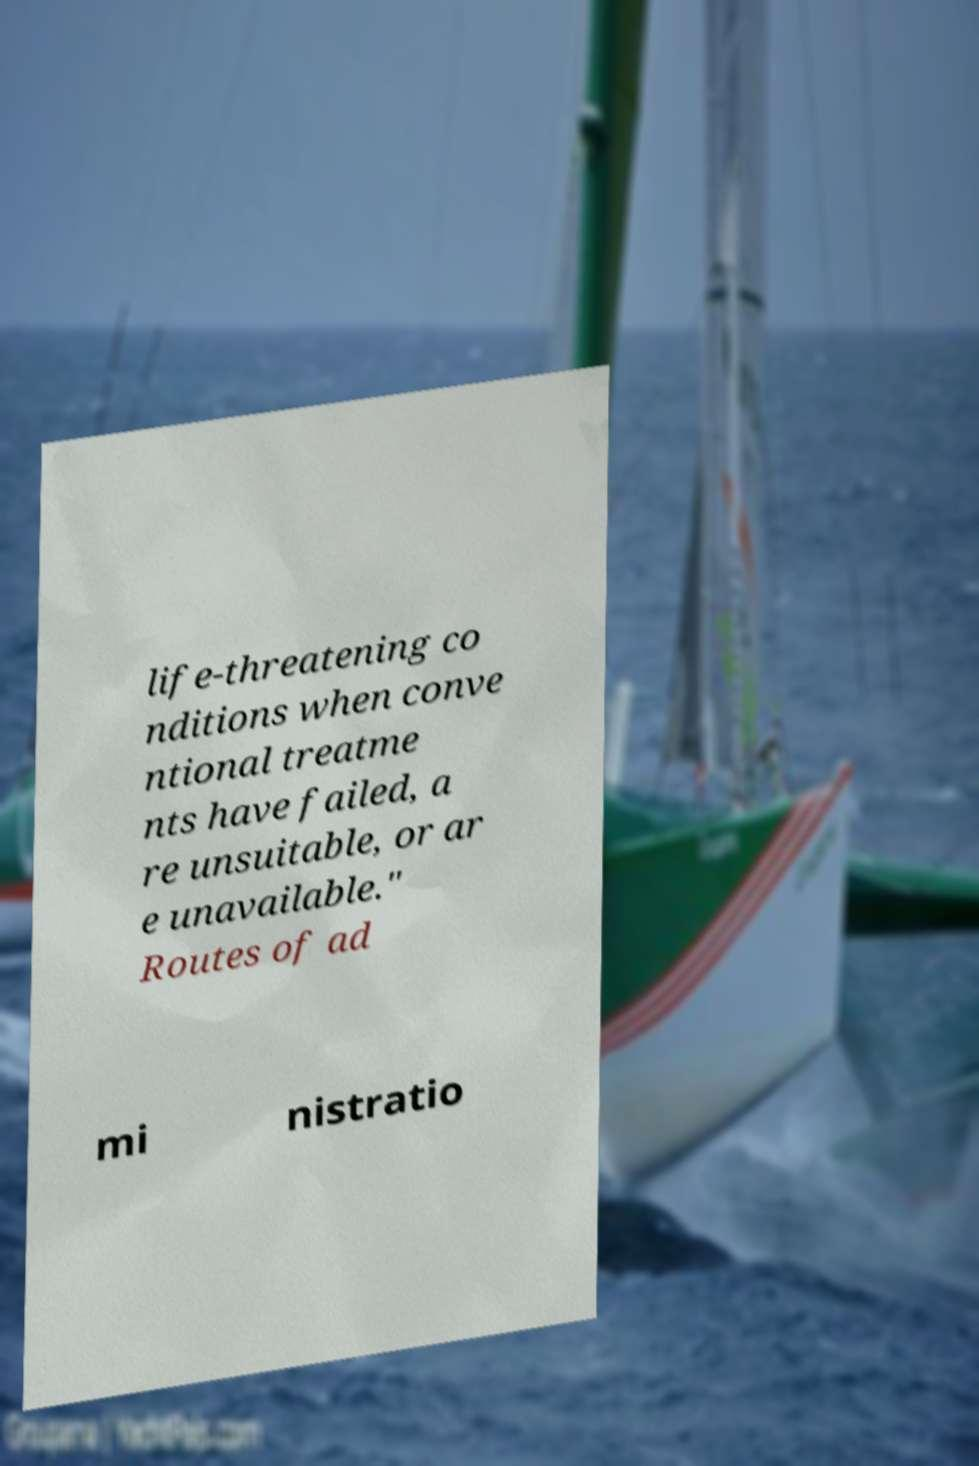I need the written content from this picture converted into text. Can you do that? life-threatening co nditions when conve ntional treatme nts have failed, a re unsuitable, or ar e unavailable." Routes of ad mi nistratio 